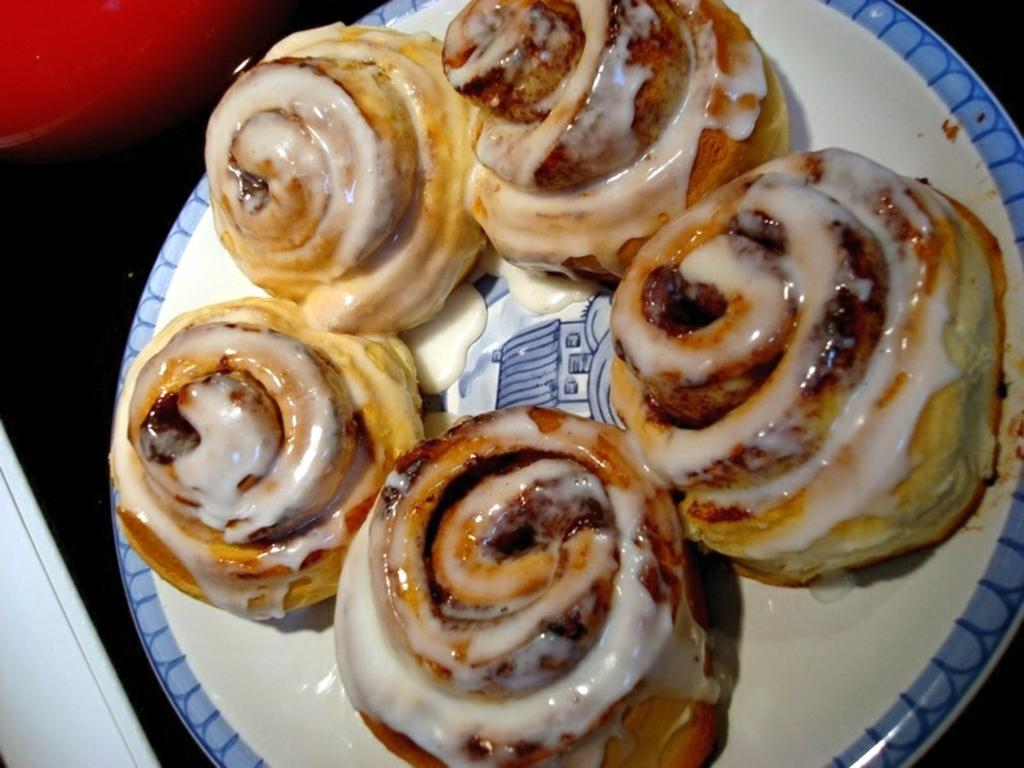What is on the plate that is visible in the image? There is food on a plate in the image. Can you describe any other objects in the image besides the plate of food? Unfortunately, the provided facts only mention that there are some unspecified objects in the image. What type of jam is being spread on the ear in the image? There is no jam or ear present in the image. 